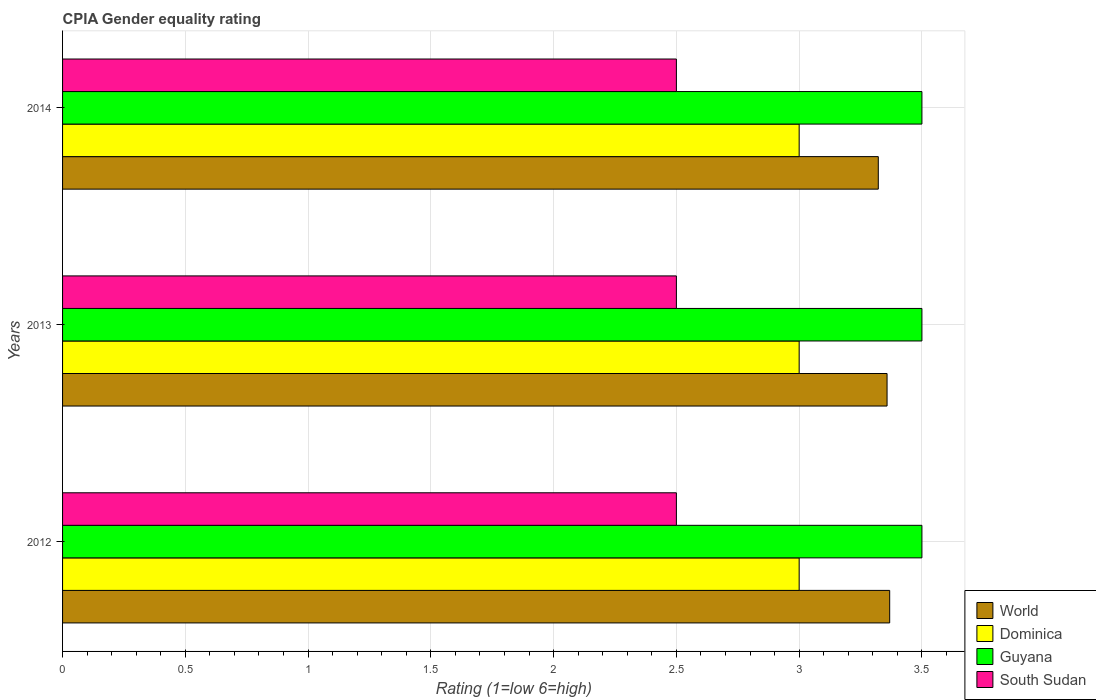How many different coloured bars are there?
Make the answer very short. 4. Are the number of bars per tick equal to the number of legend labels?
Make the answer very short. Yes. Are the number of bars on each tick of the Y-axis equal?
Your response must be concise. Yes. Across all years, what is the maximum CPIA rating in Guyana?
Keep it short and to the point. 3.5. In which year was the CPIA rating in Guyana maximum?
Ensure brevity in your answer.  2012. In which year was the CPIA rating in World minimum?
Provide a short and direct response. 2014. What is the difference between the CPIA rating in Dominica in 2012 and that in 2013?
Keep it short and to the point. 0. In the year 2014, what is the difference between the CPIA rating in World and CPIA rating in Dominica?
Your answer should be very brief. 0.32. In how many years, is the CPIA rating in Guyana greater than 2.4 ?
Your answer should be very brief. 3. What is the ratio of the CPIA rating in World in 2012 to that in 2013?
Provide a succinct answer. 1. Is the difference between the CPIA rating in World in 2012 and 2013 greater than the difference between the CPIA rating in Dominica in 2012 and 2013?
Your response must be concise. Yes. What is the difference between the highest and the second highest CPIA rating in World?
Give a very brief answer. 0.01. Is the sum of the CPIA rating in Dominica in 2012 and 2014 greater than the maximum CPIA rating in Guyana across all years?
Offer a very short reply. Yes. What does the 4th bar from the top in 2014 represents?
Offer a terse response. World. What does the 1st bar from the bottom in 2012 represents?
Your response must be concise. World. How many bars are there?
Ensure brevity in your answer.  12. Are all the bars in the graph horizontal?
Your response must be concise. Yes. What is the difference between two consecutive major ticks on the X-axis?
Keep it short and to the point. 0.5. Does the graph contain any zero values?
Ensure brevity in your answer.  No. How are the legend labels stacked?
Your answer should be very brief. Vertical. What is the title of the graph?
Provide a short and direct response. CPIA Gender equality rating. What is the label or title of the X-axis?
Give a very brief answer. Rating (1=low 6=high). What is the Rating (1=low 6=high) in World in 2012?
Provide a short and direct response. 3.37. What is the Rating (1=low 6=high) in South Sudan in 2012?
Provide a short and direct response. 2.5. What is the Rating (1=low 6=high) of World in 2013?
Offer a very short reply. 3.36. What is the Rating (1=low 6=high) in Dominica in 2013?
Offer a terse response. 3. What is the Rating (1=low 6=high) in Guyana in 2013?
Keep it short and to the point. 3.5. What is the Rating (1=low 6=high) in South Sudan in 2013?
Your answer should be compact. 2.5. What is the Rating (1=low 6=high) in World in 2014?
Your response must be concise. 3.32. What is the Rating (1=low 6=high) of South Sudan in 2014?
Make the answer very short. 2.5. Across all years, what is the maximum Rating (1=low 6=high) of World?
Keep it short and to the point. 3.37. Across all years, what is the maximum Rating (1=low 6=high) of Dominica?
Provide a succinct answer. 3. Across all years, what is the maximum Rating (1=low 6=high) in Guyana?
Your answer should be compact. 3.5. Across all years, what is the maximum Rating (1=low 6=high) of South Sudan?
Offer a very short reply. 2.5. Across all years, what is the minimum Rating (1=low 6=high) in World?
Your answer should be compact. 3.32. Across all years, what is the minimum Rating (1=low 6=high) in Guyana?
Offer a terse response. 3.5. What is the total Rating (1=low 6=high) in World in the graph?
Give a very brief answer. 10.05. What is the total Rating (1=low 6=high) in South Sudan in the graph?
Offer a very short reply. 7.5. What is the difference between the Rating (1=low 6=high) of World in 2012 and that in 2013?
Offer a very short reply. 0.01. What is the difference between the Rating (1=low 6=high) in South Sudan in 2012 and that in 2013?
Offer a terse response. 0. What is the difference between the Rating (1=low 6=high) of World in 2012 and that in 2014?
Provide a short and direct response. 0.05. What is the difference between the Rating (1=low 6=high) of Guyana in 2012 and that in 2014?
Your answer should be compact. 0. What is the difference between the Rating (1=low 6=high) of South Sudan in 2012 and that in 2014?
Provide a short and direct response. 0. What is the difference between the Rating (1=low 6=high) of World in 2013 and that in 2014?
Provide a short and direct response. 0.04. What is the difference between the Rating (1=low 6=high) of Guyana in 2013 and that in 2014?
Your response must be concise. 0. What is the difference between the Rating (1=low 6=high) in South Sudan in 2013 and that in 2014?
Make the answer very short. 0. What is the difference between the Rating (1=low 6=high) of World in 2012 and the Rating (1=low 6=high) of Dominica in 2013?
Keep it short and to the point. 0.37. What is the difference between the Rating (1=low 6=high) in World in 2012 and the Rating (1=low 6=high) in Guyana in 2013?
Your answer should be compact. -0.13. What is the difference between the Rating (1=low 6=high) of World in 2012 and the Rating (1=low 6=high) of South Sudan in 2013?
Give a very brief answer. 0.87. What is the difference between the Rating (1=low 6=high) in Dominica in 2012 and the Rating (1=low 6=high) in Guyana in 2013?
Provide a short and direct response. -0.5. What is the difference between the Rating (1=low 6=high) of Dominica in 2012 and the Rating (1=low 6=high) of South Sudan in 2013?
Keep it short and to the point. 0.5. What is the difference between the Rating (1=low 6=high) of World in 2012 and the Rating (1=low 6=high) of Dominica in 2014?
Your response must be concise. 0.37. What is the difference between the Rating (1=low 6=high) of World in 2012 and the Rating (1=low 6=high) of Guyana in 2014?
Keep it short and to the point. -0.13. What is the difference between the Rating (1=low 6=high) of World in 2012 and the Rating (1=low 6=high) of South Sudan in 2014?
Keep it short and to the point. 0.87. What is the difference between the Rating (1=low 6=high) of Dominica in 2012 and the Rating (1=low 6=high) of Guyana in 2014?
Your response must be concise. -0.5. What is the difference between the Rating (1=low 6=high) in Guyana in 2012 and the Rating (1=low 6=high) in South Sudan in 2014?
Ensure brevity in your answer.  1. What is the difference between the Rating (1=low 6=high) of World in 2013 and the Rating (1=low 6=high) of Dominica in 2014?
Ensure brevity in your answer.  0.36. What is the difference between the Rating (1=low 6=high) in World in 2013 and the Rating (1=low 6=high) in Guyana in 2014?
Offer a terse response. -0.14. What is the difference between the Rating (1=low 6=high) of World in 2013 and the Rating (1=low 6=high) of South Sudan in 2014?
Your answer should be very brief. 0.86. What is the difference between the Rating (1=low 6=high) of Dominica in 2013 and the Rating (1=low 6=high) of Guyana in 2014?
Offer a very short reply. -0.5. What is the difference between the Rating (1=low 6=high) of Guyana in 2013 and the Rating (1=low 6=high) of South Sudan in 2014?
Your response must be concise. 1. What is the average Rating (1=low 6=high) in World per year?
Your answer should be compact. 3.35. In the year 2012, what is the difference between the Rating (1=low 6=high) of World and Rating (1=low 6=high) of Dominica?
Ensure brevity in your answer.  0.37. In the year 2012, what is the difference between the Rating (1=low 6=high) in World and Rating (1=low 6=high) in Guyana?
Offer a terse response. -0.13. In the year 2012, what is the difference between the Rating (1=low 6=high) of World and Rating (1=low 6=high) of South Sudan?
Offer a very short reply. 0.87. In the year 2012, what is the difference between the Rating (1=low 6=high) of Dominica and Rating (1=low 6=high) of Guyana?
Provide a succinct answer. -0.5. In the year 2012, what is the difference between the Rating (1=low 6=high) of Dominica and Rating (1=low 6=high) of South Sudan?
Ensure brevity in your answer.  0.5. In the year 2013, what is the difference between the Rating (1=low 6=high) in World and Rating (1=low 6=high) in Dominica?
Your answer should be compact. 0.36. In the year 2013, what is the difference between the Rating (1=low 6=high) in World and Rating (1=low 6=high) in Guyana?
Make the answer very short. -0.14. In the year 2013, what is the difference between the Rating (1=low 6=high) of World and Rating (1=low 6=high) of South Sudan?
Offer a very short reply. 0.86. In the year 2014, what is the difference between the Rating (1=low 6=high) in World and Rating (1=low 6=high) in Dominica?
Give a very brief answer. 0.32. In the year 2014, what is the difference between the Rating (1=low 6=high) of World and Rating (1=low 6=high) of Guyana?
Ensure brevity in your answer.  -0.18. In the year 2014, what is the difference between the Rating (1=low 6=high) of World and Rating (1=low 6=high) of South Sudan?
Provide a short and direct response. 0.82. In the year 2014, what is the difference between the Rating (1=low 6=high) in Dominica and Rating (1=low 6=high) in Guyana?
Offer a terse response. -0.5. What is the ratio of the Rating (1=low 6=high) of Dominica in 2012 to that in 2013?
Your answer should be very brief. 1. What is the ratio of the Rating (1=low 6=high) in Guyana in 2012 to that in 2013?
Your response must be concise. 1. What is the ratio of the Rating (1=low 6=high) of South Sudan in 2012 to that in 2013?
Ensure brevity in your answer.  1. What is the ratio of the Rating (1=low 6=high) in Guyana in 2012 to that in 2014?
Your answer should be very brief. 1. What is the ratio of the Rating (1=low 6=high) of South Sudan in 2012 to that in 2014?
Make the answer very short. 1. What is the ratio of the Rating (1=low 6=high) in World in 2013 to that in 2014?
Keep it short and to the point. 1.01. What is the ratio of the Rating (1=low 6=high) in Dominica in 2013 to that in 2014?
Give a very brief answer. 1. What is the ratio of the Rating (1=low 6=high) of Guyana in 2013 to that in 2014?
Keep it short and to the point. 1. What is the ratio of the Rating (1=low 6=high) of South Sudan in 2013 to that in 2014?
Offer a very short reply. 1. What is the difference between the highest and the second highest Rating (1=low 6=high) in World?
Your answer should be compact. 0.01. What is the difference between the highest and the second highest Rating (1=low 6=high) of Guyana?
Provide a short and direct response. 0. What is the difference between the highest and the lowest Rating (1=low 6=high) in World?
Your answer should be compact. 0.05. What is the difference between the highest and the lowest Rating (1=low 6=high) of Dominica?
Offer a terse response. 0. What is the difference between the highest and the lowest Rating (1=low 6=high) in Guyana?
Your answer should be very brief. 0. What is the difference between the highest and the lowest Rating (1=low 6=high) in South Sudan?
Your response must be concise. 0. 